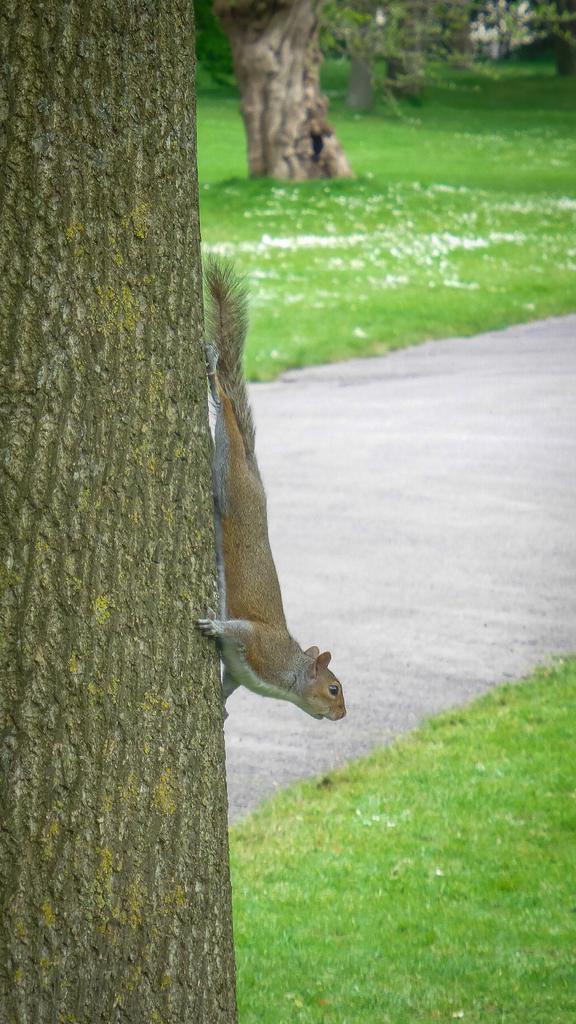Please provide a concise description of this image. In this image there is a squirrel on a tree trunk. Behind the tree there is a road. In the background there are trees and grass on the ground. At the bottom there is grass. 